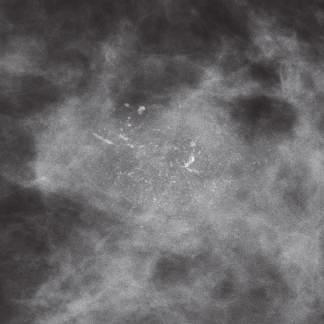what is associated with dcis?
Answer the question using a single word or phrase. Mammographic detection of calcifications 